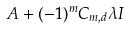Convert formula to latex. <formula><loc_0><loc_0><loc_500><loc_500>A + ( - 1 ) ^ { m } C _ { m , d } \lambda I</formula> 